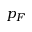Convert formula to latex. <formula><loc_0><loc_0><loc_500><loc_500>p _ { F }</formula> 